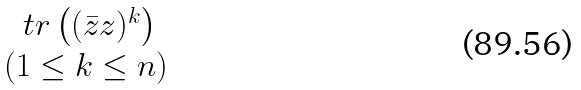Convert formula to latex. <formula><loc_0><loc_0><loc_500><loc_500>\begin{matrix} \ t r \left ( ( \bar { z } z ) ^ { k } \right ) \\ ( 1 \leq k \leq n ) \end{matrix}</formula> 